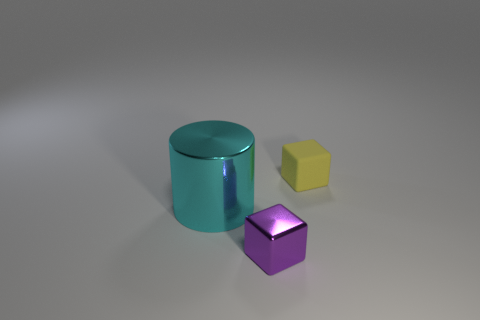What number of things are either cyan blocks or small metal objects?
Make the answer very short. 1. Do the cyan object and the cube that is in front of the cyan cylinder have the same size?
Provide a succinct answer. No. What number of other objects are there of the same material as the tiny yellow thing?
Keep it short and to the point. 0. How many objects are either small objects in front of the cyan metallic thing or blocks in front of the shiny cylinder?
Your answer should be compact. 1. What material is the small yellow object that is the same shape as the purple object?
Ensure brevity in your answer.  Rubber. Is there a gray cube?
Keep it short and to the point. No. There is a thing that is behind the tiny metallic block and on the left side of the yellow rubber object; what is its size?
Offer a terse response. Large. The cyan metal thing is what shape?
Your answer should be compact. Cylinder. There is a small object that is in front of the cyan thing; is there a purple thing that is on the right side of it?
Give a very brief answer. No. What material is the yellow thing that is the same size as the purple metallic thing?
Your response must be concise. Rubber. 